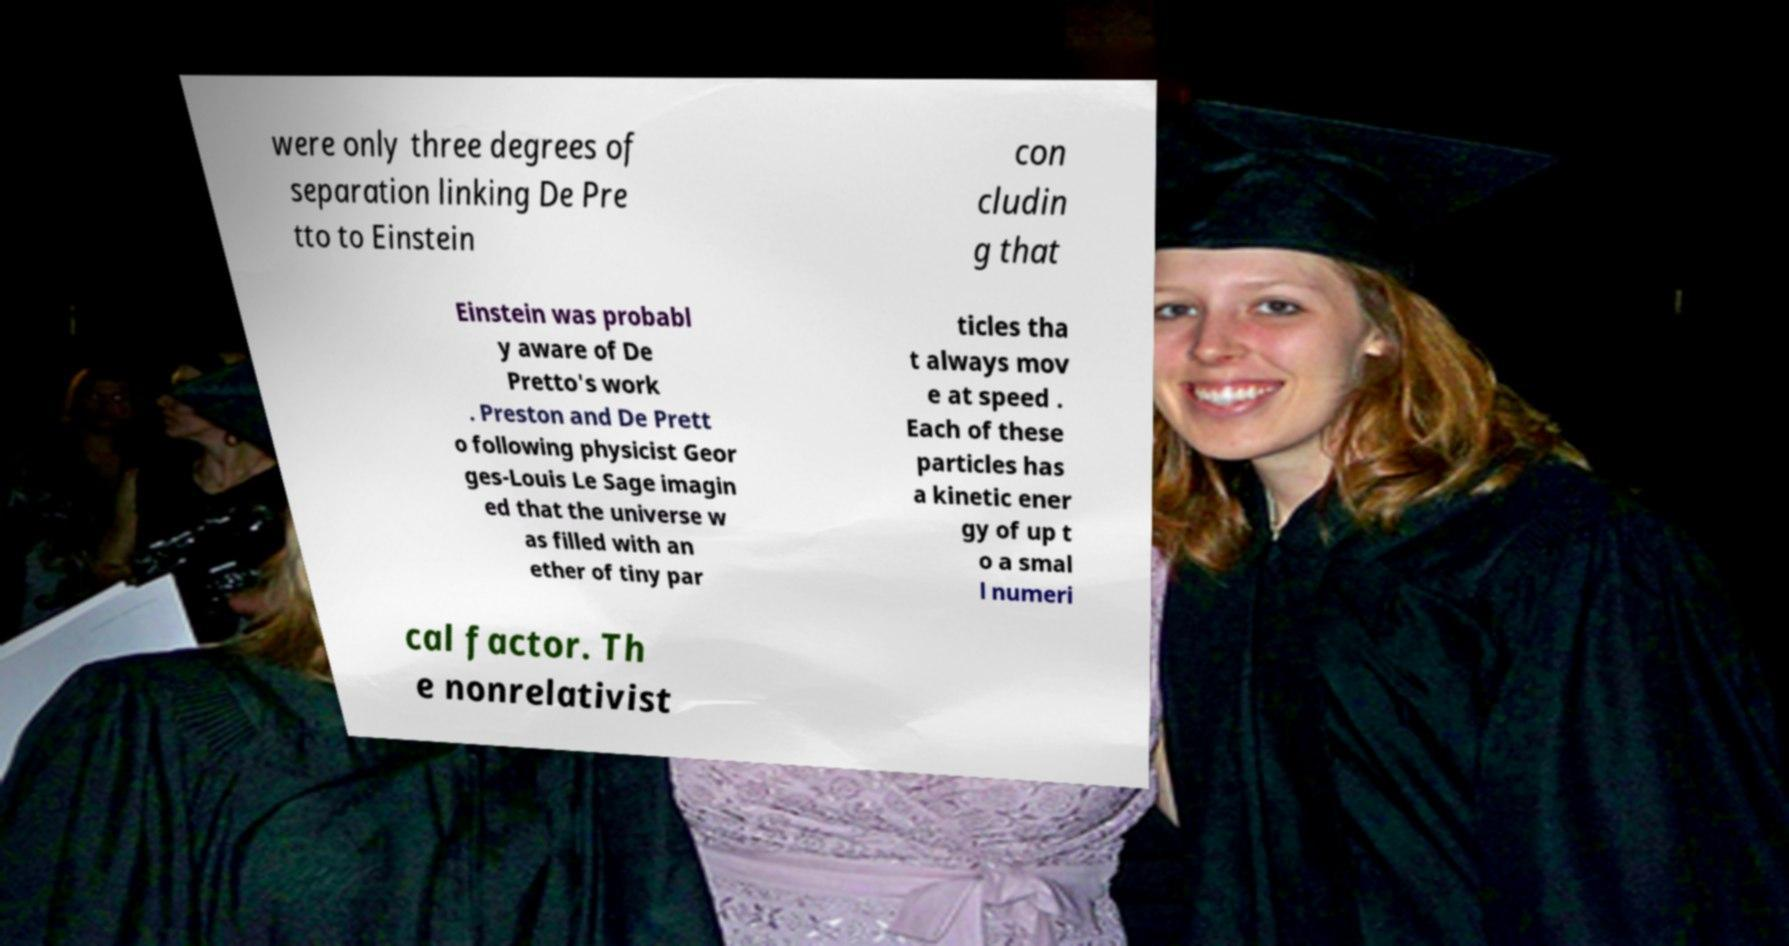Could you assist in decoding the text presented in this image and type it out clearly? were only three degrees of separation linking De Pre tto to Einstein con cludin g that Einstein was probabl y aware of De Pretto's work . Preston and De Prett o following physicist Geor ges-Louis Le Sage imagin ed that the universe w as filled with an ether of tiny par ticles tha t always mov e at speed . Each of these particles has a kinetic ener gy of up t o a smal l numeri cal factor. Th e nonrelativist 